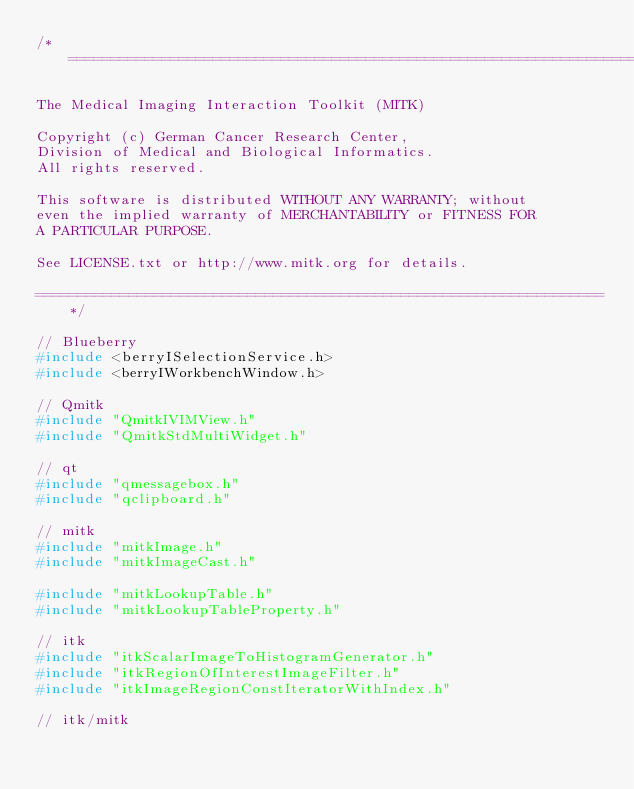Convert code to text. <code><loc_0><loc_0><loc_500><loc_500><_C++_>/*===================================================================

The Medical Imaging Interaction Toolkit (MITK)

Copyright (c) German Cancer Research Center,
Division of Medical and Biological Informatics.
All rights reserved.

This software is distributed WITHOUT ANY WARRANTY; without
even the implied warranty of MERCHANTABILITY or FITNESS FOR
A PARTICULAR PURPOSE.

See LICENSE.txt or http://www.mitk.org for details.

===================================================================*/

// Blueberry
#include <berryISelectionService.h>
#include <berryIWorkbenchWindow.h>

// Qmitk
#include "QmitkIVIMView.h"
#include "QmitkStdMultiWidget.h"

// qt
#include "qmessagebox.h"
#include "qclipboard.h"

// mitk
#include "mitkImage.h"
#include "mitkImageCast.h"

#include "mitkLookupTable.h"
#include "mitkLookupTableProperty.h"

// itk
#include "itkScalarImageToHistogramGenerator.h"
#include "itkRegionOfInterestImageFilter.h"
#include "itkImageRegionConstIteratorWithIndex.h"

// itk/mitk</code> 